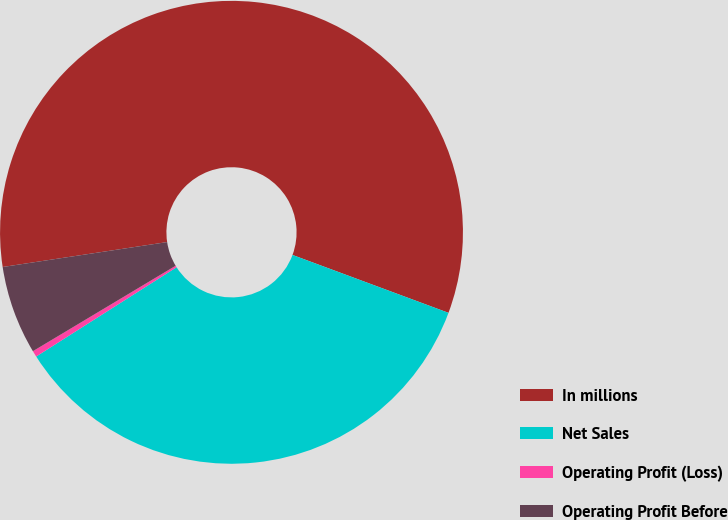Convert chart. <chart><loc_0><loc_0><loc_500><loc_500><pie_chart><fcel>In millions<fcel>Net Sales<fcel>Operating Profit (Loss)<fcel>Operating Profit Before<nl><fcel>58.05%<fcel>35.33%<fcel>0.43%<fcel>6.19%<nl></chart> 